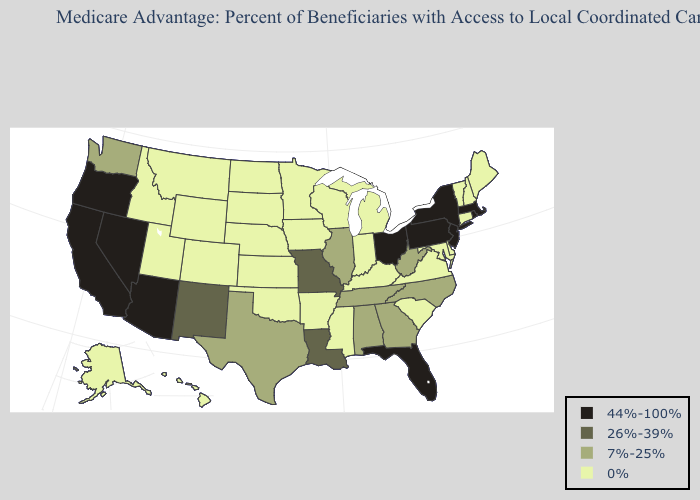Does Vermont have the lowest value in the USA?
Be succinct. Yes. What is the value of Texas?
Concise answer only. 7%-25%. Which states have the lowest value in the USA?
Concise answer only. Alaska, Arkansas, Colorado, Connecticut, Delaware, Hawaii, Iowa, Idaho, Indiana, Kansas, Kentucky, Maryland, Maine, Michigan, Minnesota, Mississippi, Montana, North Dakota, Nebraska, New Hampshire, Oklahoma, South Carolina, South Dakota, Utah, Virginia, Vermont, Wisconsin, Wyoming. Name the states that have a value in the range 44%-100%?
Give a very brief answer. Arizona, California, Florida, Massachusetts, New Jersey, Nevada, New York, Ohio, Oregon, Pennsylvania, Rhode Island. What is the highest value in the MidWest ?
Be succinct. 44%-100%. What is the value of Indiana?
Be succinct. 0%. What is the value of New Jersey?
Give a very brief answer. 44%-100%. What is the value of Rhode Island?
Give a very brief answer. 44%-100%. Name the states that have a value in the range 44%-100%?
Answer briefly. Arizona, California, Florida, Massachusetts, New Jersey, Nevada, New York, Ohio, Oregon, Pennsylvania, Rhode Island. What is the value of Illinois?
Concise answer only. 7%-25%. Name the states that have a value in the range 0%?
Concise answer only. Alaska, Arkansas, Colorado, Connecticut, Delaware, Hawaii, Iowa, Idaho, Indiana, Kansas, Kentucky, Maryland, Maine, Michigan, Minnesota, Mississippi, Montana, North Dakota, Nebraska, New Hampshire, Oklahoma, South Carolina, South Dakota, Utah, Virginia, Vermont, Wisconsin, Wyoming. What is the value of Pennsylvania?
Be succinct. 44%-100%. Does Montana have the highest value in the USA?
Write a very short answer. No. What is the value of Missouri?
Concise answer only. 26%-39%. What is the value of Pennsylvania?
Write a very short answer. 44%-100%. 